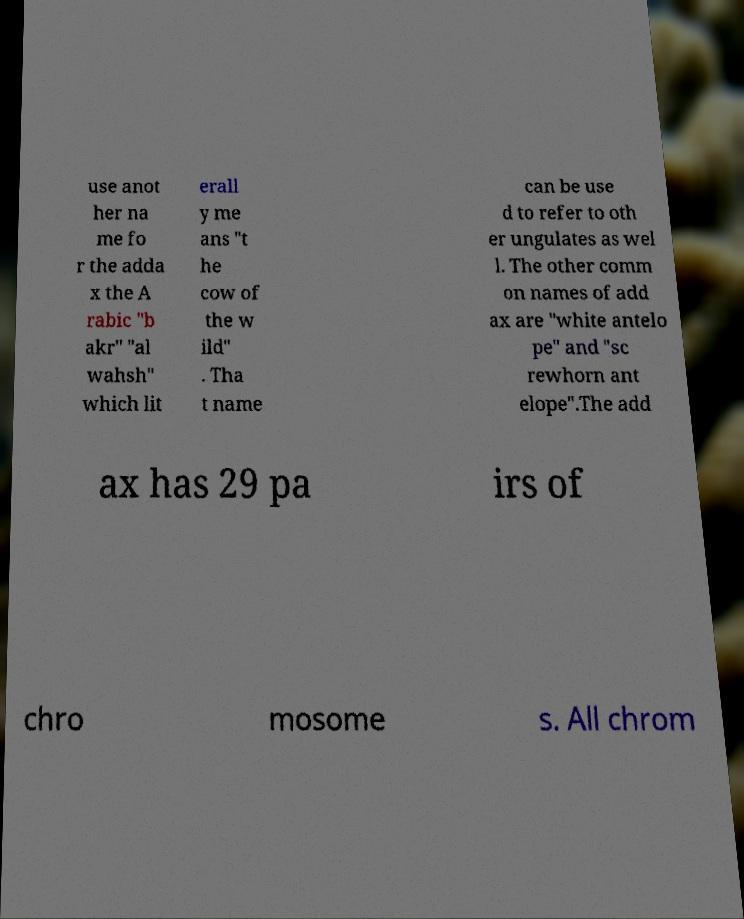Can you accurately transcribe the text from the provided image for me? use anot her na me fo r the adda x the A rabic "b akr" "al wahsh" which lit erall y me ans "t he cow of the w ild" . Tha t name can be use d to refer to oth er ungulates as wel l. The other comm on names of add ax are "white antelo pe" and "sc rewhorn ant elope".The add ax has 29 pa irs of chro mosome s. All chrom 